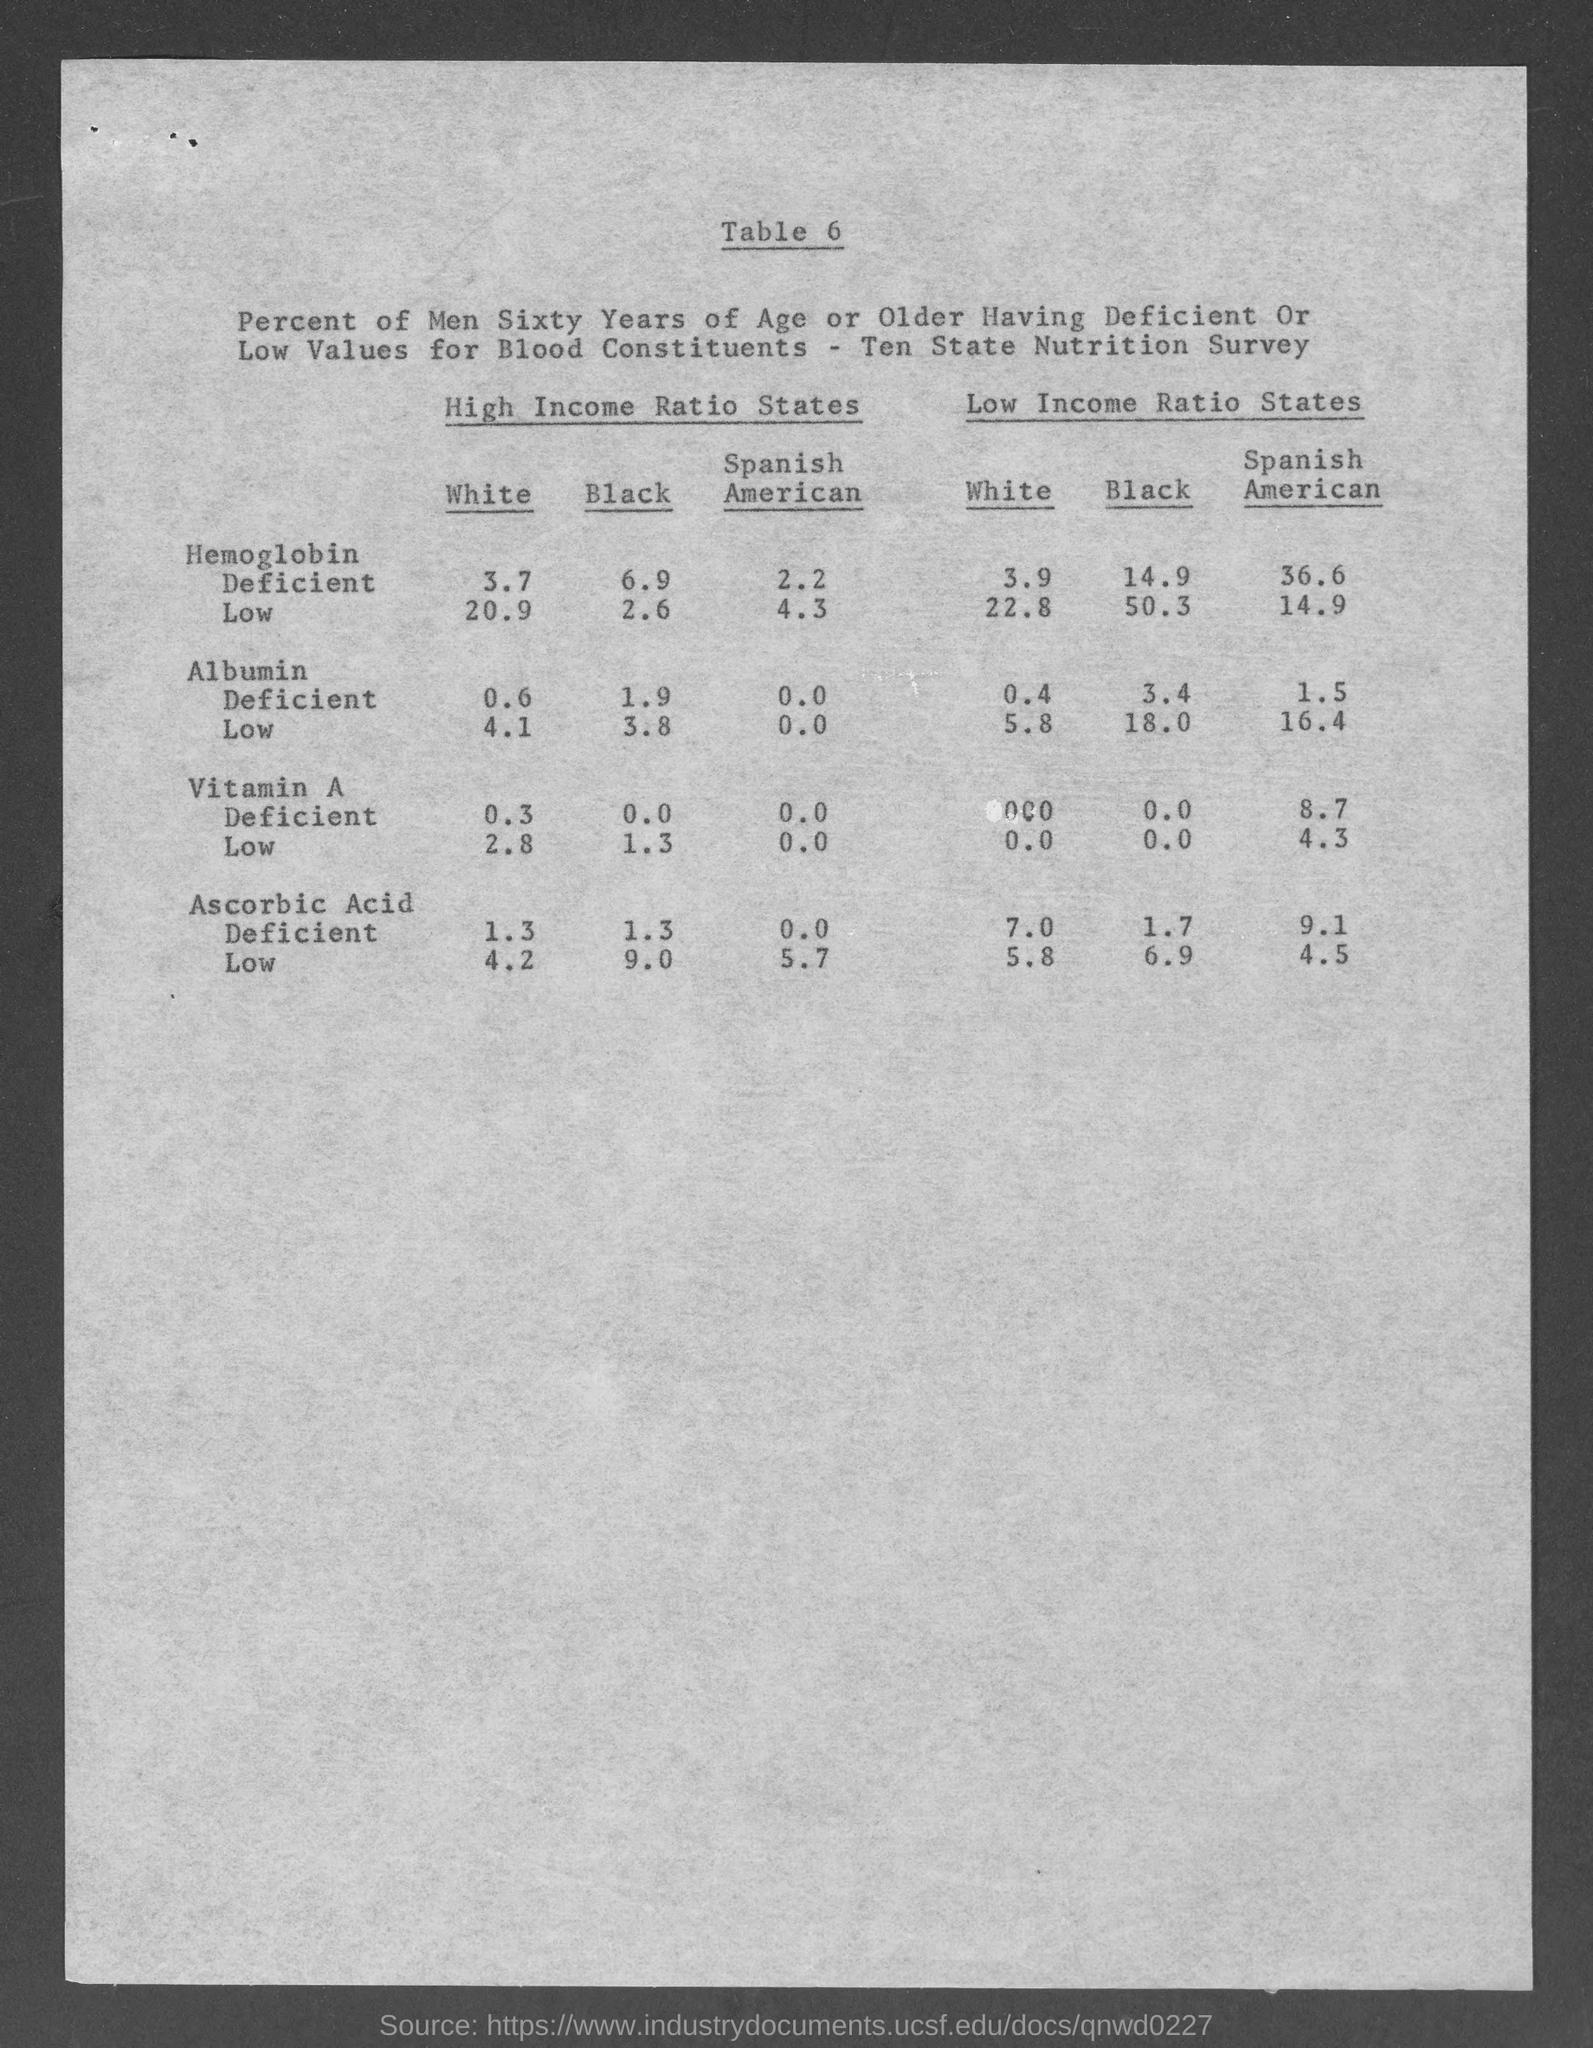Point out several critical features in this image. Please provide the table number. It is located in Table 6. In high-income ratio states, approximately 3.7% of white persons are hemoglobin deficient. A study found that among Spanish-speaking Americans living in low-income states, 8.7% were deficient in vitamin A. The prevalence of Vitamin A deficiency among Spanish-speaking Americans in high-income states is low. In low-income ratio states, approximately 14.9% of black persons are hemoglobin deficient. 